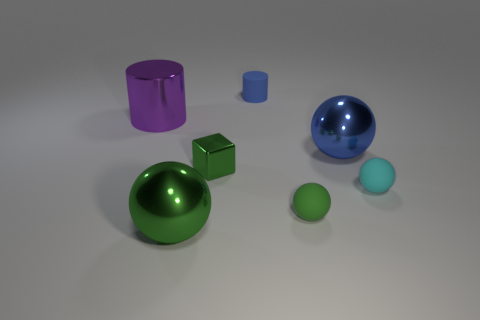Subtract all large green metal balls. How many balls are left? 3 Subtract all purple balls. Subtract all blue cylinders. How many balls are left? 4 Add 3 large cylinders. How many objects exist? 10 Subtract all cylinders. How many objects are left? 5 Add 5 metal blocks. How many metal blocks exist? 6 Subtract 0 green cylinders. How many objects are left? 7 Subtract all big purple rubber cylinders. Subtract all blue rubber things. How many objects are left? 6 Add 2 large metal cylinders. How many large metal cylinders are left? 3 